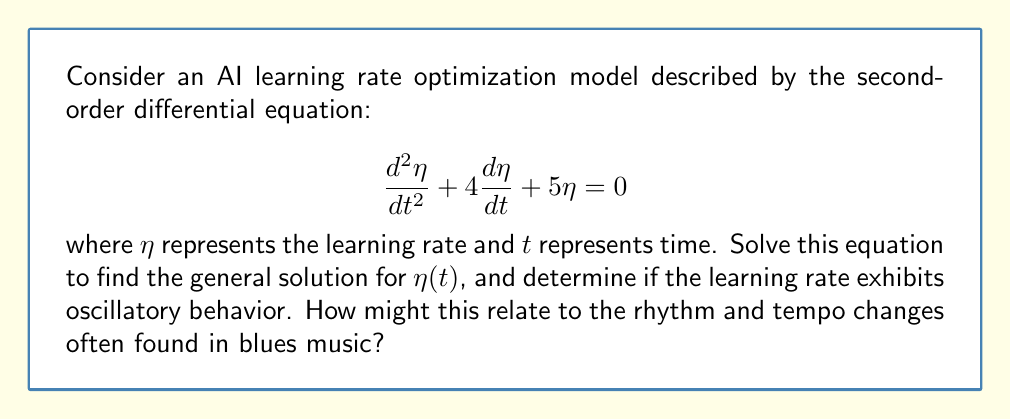Can you solve this math problem? To solve this second-order linear differential equation, we follow these steps:

1) First, we identify the characteristic equation:
   $$r^2 + 4r + 5 = 0$$

2) We solve this quadratic equation:
   $$r = \frac{-4 \pm \sqrt{4^2 - 4(1)(5)}}{2(1)} = \frac{-4 \pm \sqrt{16 - 20}}{2} = \frac{-4 \pm \sqrt{-4}}{2}$$

3) This gives us complex roots:
   $$r = -2 \pm i$$

4) The general solution for a second-order linear differential equation with complex roots $a \pm bi$ is:
   $$\eta(t) = e^{at}(c_1\cos(bt) + c_2\sin(bt))$$

   Where $c_1$ and $c_2$ are arbitrary constants.

5) Substituting our values $a=-2$ and $b=1$:
   $$\eta(t) = e^{-2t}(c_1\cos(t) + c_2\sin(t))$$

6) To determine if the learning rate exhibits oscillatory behavior, we look at the nature of the solution. The presence of sine and cosine terms indicates oscillatory behavior, but the $e^{-2t}$ term causes these oscillations to decay over time.

This behavior is analogous to the rhythm in blues music, where there's often a steady, oscillating beat (represented by the sine and cosine terms) that may gradually slow down or fade out at the end of a piece (represented by the decaying exponential term).
Answer: The general solution is:
$$\eta(t) = e^{-2t}(c_1\cos(t) + c_2\sin(t))$$
where $c_1$ and $c_2$ are arbitrary constants.

The learning rate exhibits damped oscillatory behavior, decreasing in amplitude over time. 